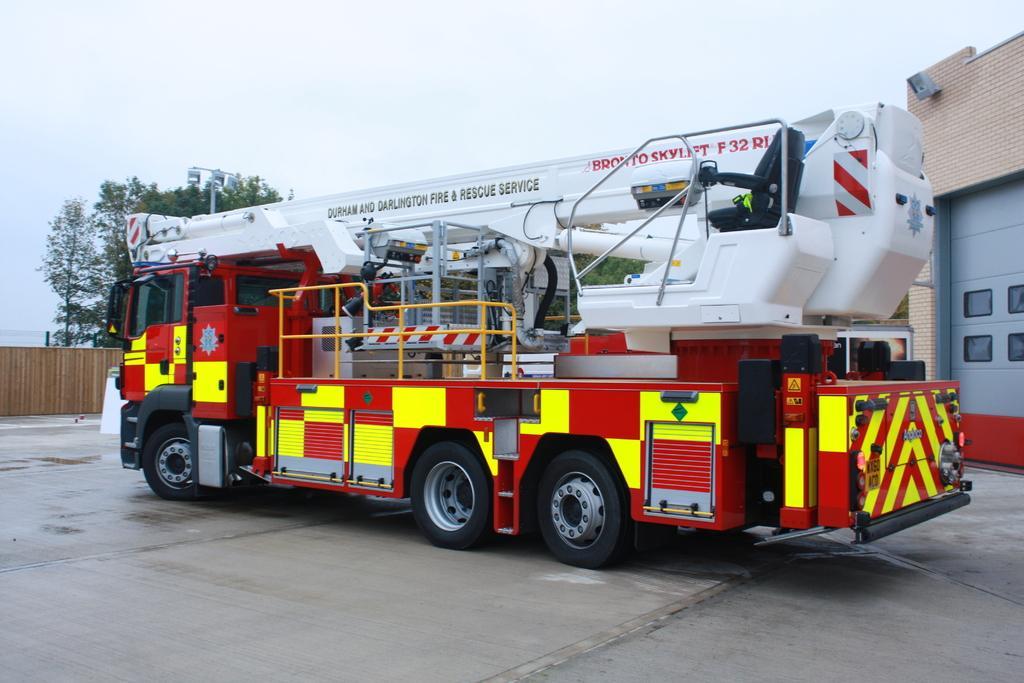Describe this image in one or two sentences. In the middle of the picture, we see a vehicle in red, white and yellow color. At the bottom, we see the road. On the right side, we see a building. On the left side, we see the wooden fence. Behind that, we see the trees and a street light. At the top, we see the sky. 